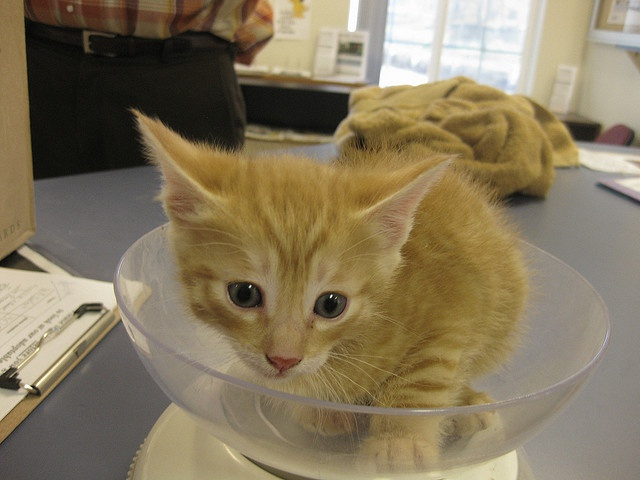Describe the objects in this image and their specific colors. I can see cat in olive and tan tones, bowl in olive and gray tones, people in olive, black, maroon, and gray tones, and book in olive, tan, darkgray, and gray tones in this image. 